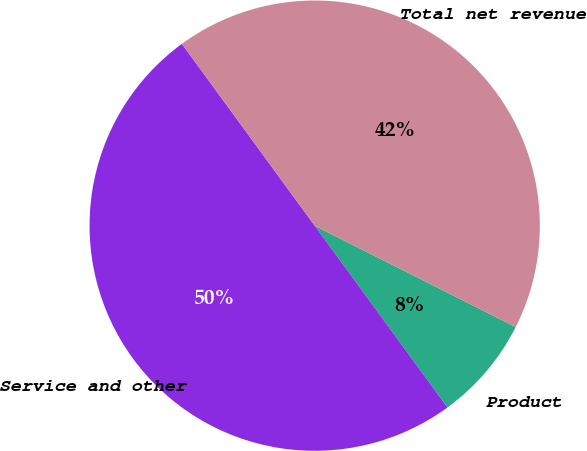Convert chart. <chart><loc_0><loc_0><loc_500><loc_500><pie_chart><fcel>Product<fcel>Service and other<fcel>Total net revenue<nl><fcel>7.52%<fcel>50.0%<fcel>42.48%<nl></chart> 